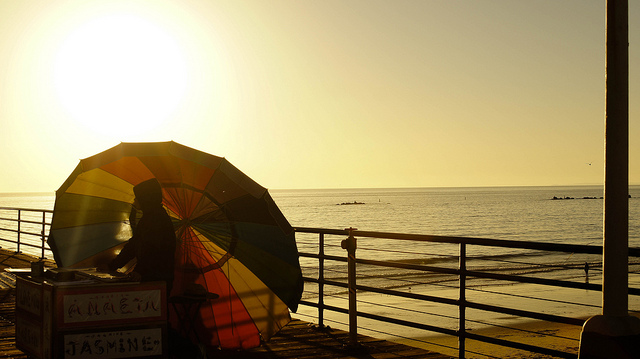What might be the purpose of the umbrella in the context of this setting? In this setting, the umbrella likely serves a practical purpose of providing shade from the sun, which seems to be strong given the sun's reflection on the sea and the warm glow in the sky. It could also be part of a small business setup, as suggested by the sign next to the umbrella, offering a cozy spot for beachgoers to enjoy the view without direct sun exposure. 